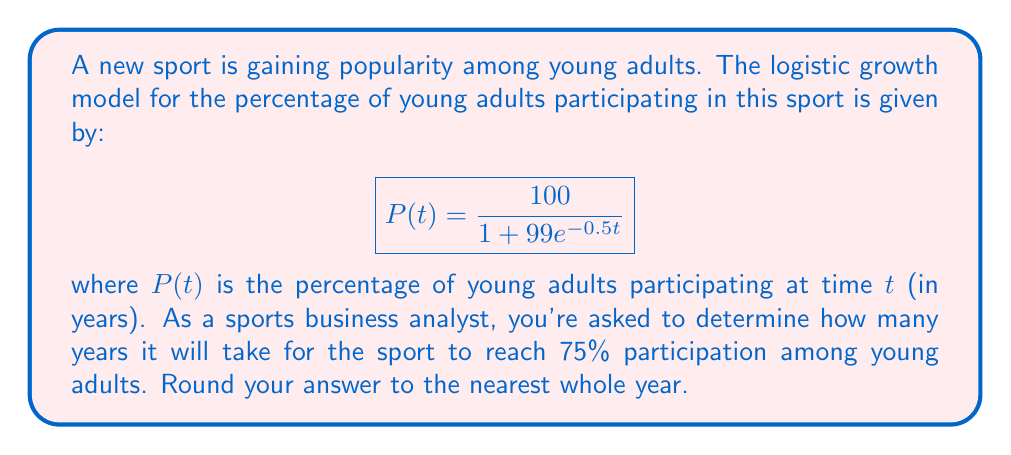Teach me how to tackle this problem. To solve this problem, we need to follow these steps:

1) We want to find $t$ when $P(t) = 75$. So, we set up the equation:

   $$75 = \frac{100}{1 + 99e^{-0.5t}}$$

2) Multiply both sides by $(1 + 99e^{-0.5t})$:

   $$75(1 + 99e^{-0.5t}) = 100$$

3) Distribute on the left side:

   $$75 + 7425e^{-0.5t} = 100$$

4) Subtract 75 from both sides:

   $$7425e^{-0.5t} = 25$$

5) Divide both sides by 7425:

   $$e^{-0.5t} = \frac{25}{7425} = \frac{1}{297}$$

6) Take the natural log of both sides:

   $$-0.5t = \ln(\frac{1}{297})$$

7) Divide both sides by -0.5:

   $$t = -\frac{\ln(\frac{1}{297})}{0.5} = \frac{\ln(297)}{0.5}$$

8) Calculate this value:

   $$t = \frac{5.69373}{0.5} = 11.3875$$

9) Rounding to the nearest whole year:

   $$t \approx 11 \text{ years}$$
Answer: 11 years 